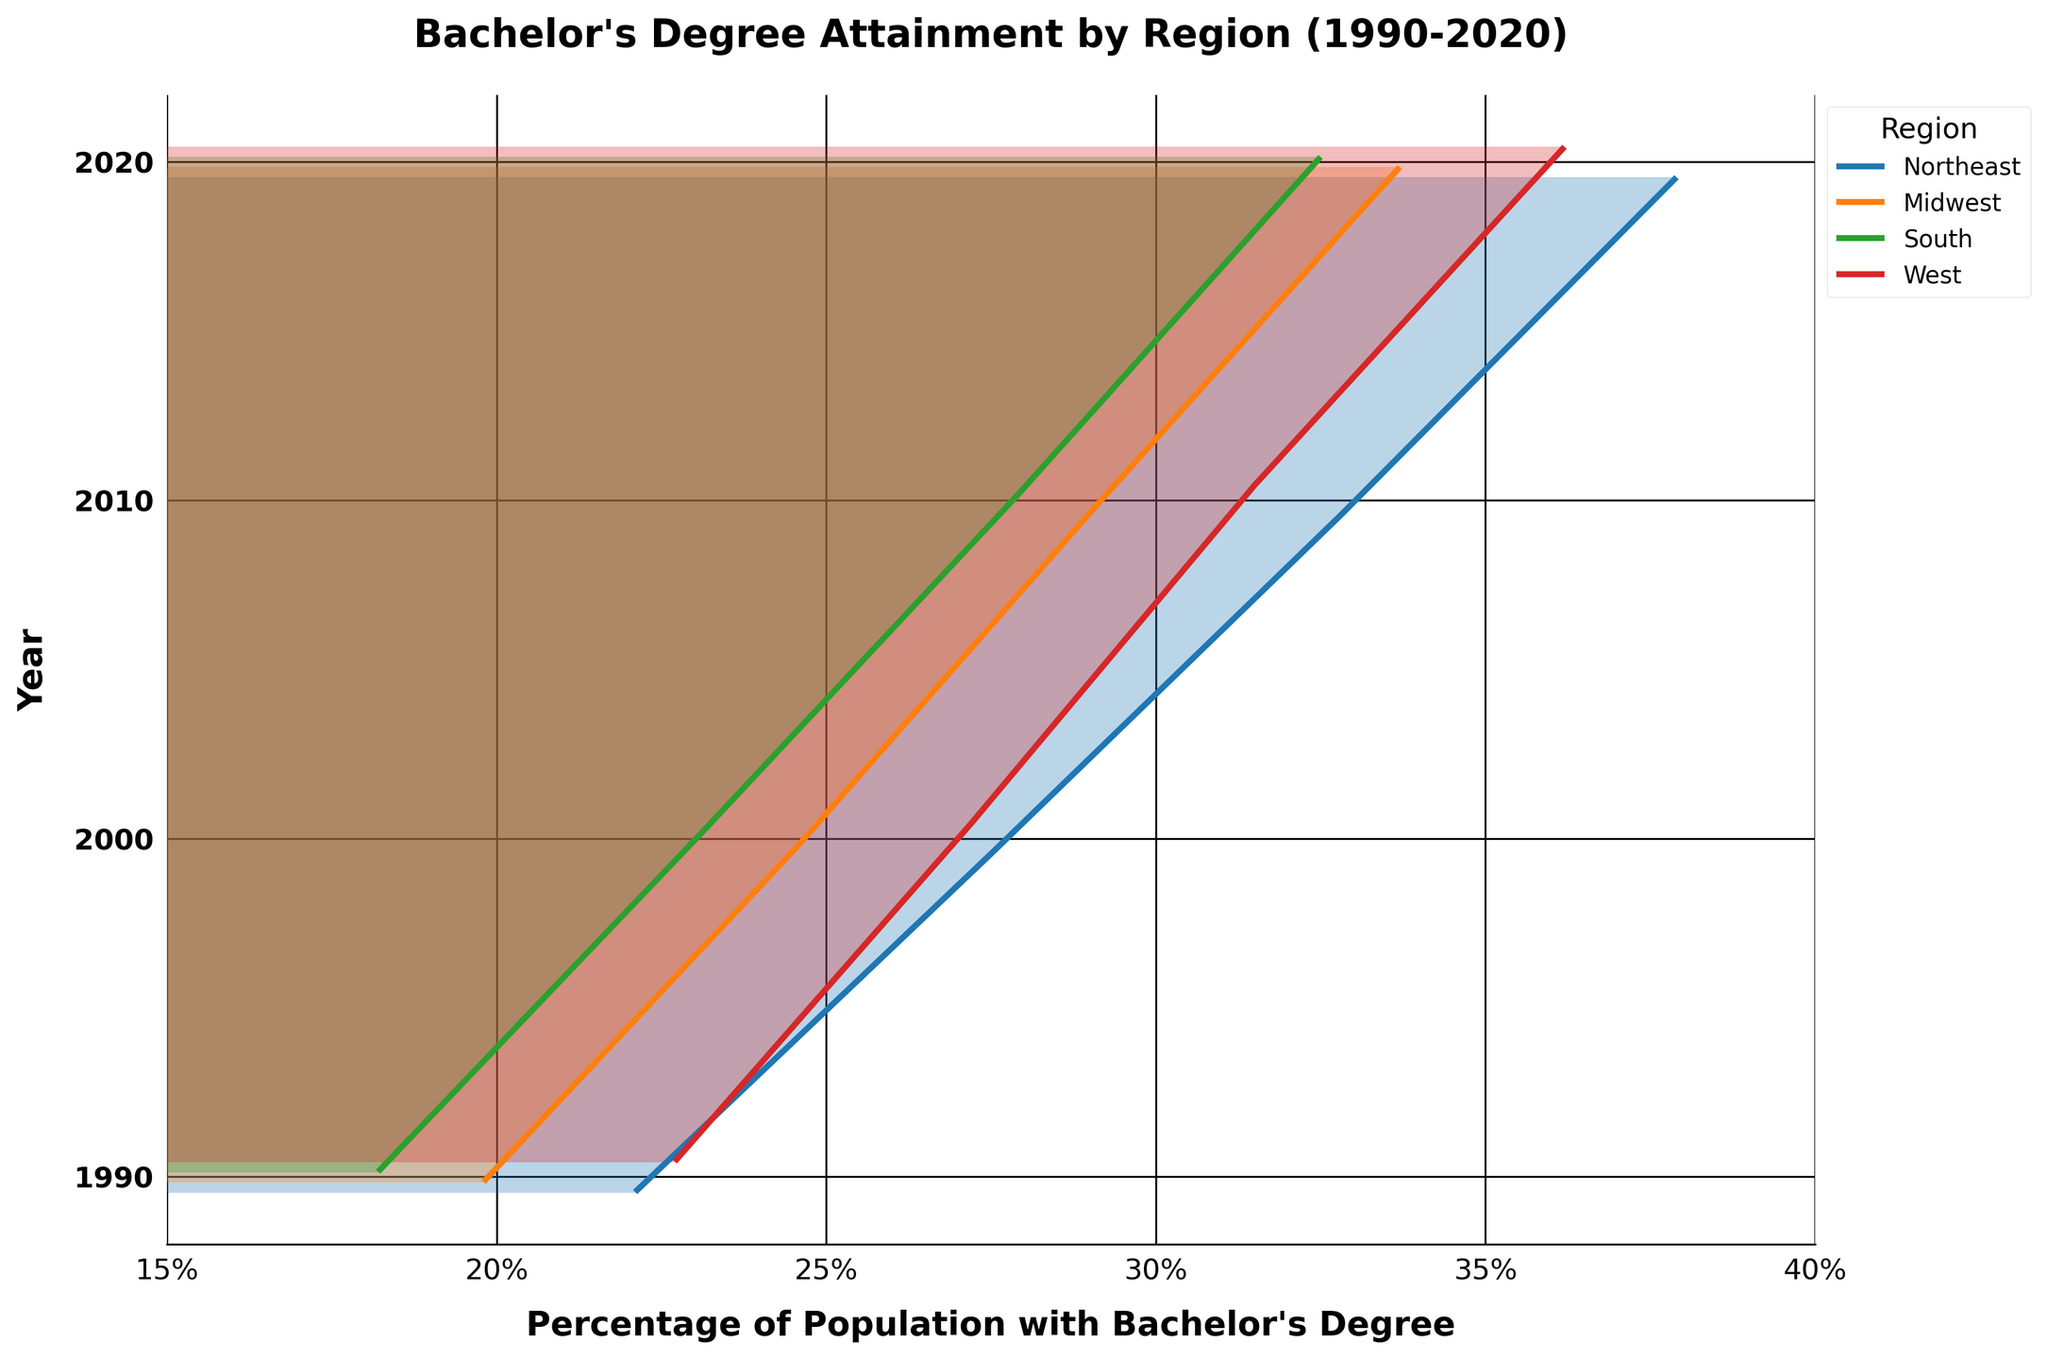What is the title of the figure? The title is typically prominently displayed at the top of the figure. In this case, it reads "Bachelor's Degree Attainment by Region (1990-2020)."
Answer: Bachelor's Degree Attainment by Region (1990-2020) What is the percentage range displayed on the x-axis? By inspecting the x-axis, we can see it ranges from 15% to 40%, with ticks marked at intervals of 5%.
Answer: 15% to 40% Which region shows the highest percentage of Bachelor’s degree attainment in 2020? The year 2020 is the last set of lines at the top. Among them, the Northeast appears highest on the x-axis, showing the highest percentage.
Answer: Northeast Between 1990 and 2020, which region had the largest increase in Bachelor’s degree attainment? Comparing the start and end points of each region's line on the x-axis, the Northeast had the largest shift to the right.
Answer: Northeast Which two regions had the closest Bachelor's degree attainment percentage in 2000? Looking at the year 2000, the lines for the West and Northeast are closest together, showing percentages near each other.
Answer: West and Northeast What was the approximate percentage of the population with a Bachelor's degree in the Midwest in 1990? The position of the line for the Midwest in 1990 is around 19.8% on the x-axis.
Answer: 19.8% Which year shows the most significant disparity in Bachelor's degree attainment between the Northeast and Midwest? Comparing the lines for these regions across years, 2020 shows the most extensive gap in their positions on the x-axis.
Answer: 2020 How does the trend of Bachelor’s degree attainment in the South compare to the West from 1990 to 2020? From 1990 to 2020, both regions show an upward trend, but the West has a steeper increase in percentage. The lines move more to the right in the West.
Answer: South increases steadily; West increases more steeply What trend is observed in educational attainment for all regions from 1990 to 2020? For each region, the lines consistently move to the right over time, indicating a general upward trend in Bachelor’s degree attainment.
Answer: General increase in Bachelor's degree attainment 